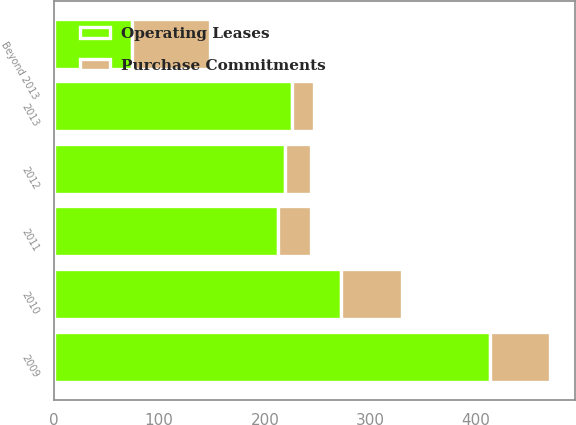<chart> <loc_0><loc_0><loc_500><loc_500><stacked_bar_chart><ecel><fcel>2009<fcel>2010<fcel>2011<fcel>2012<fcel>2013<fcel>Beyond 2013<nl><fcel>Purchase Commitments<fcel>57<fcel>58<fcel>32<fcel>25<fcel>21<fcel>74<nl><fcel>Operating Leases<fcel>413<fcel>272<fcel>212<fcel>219<fcel>226<fcel>74<nl></chart> 